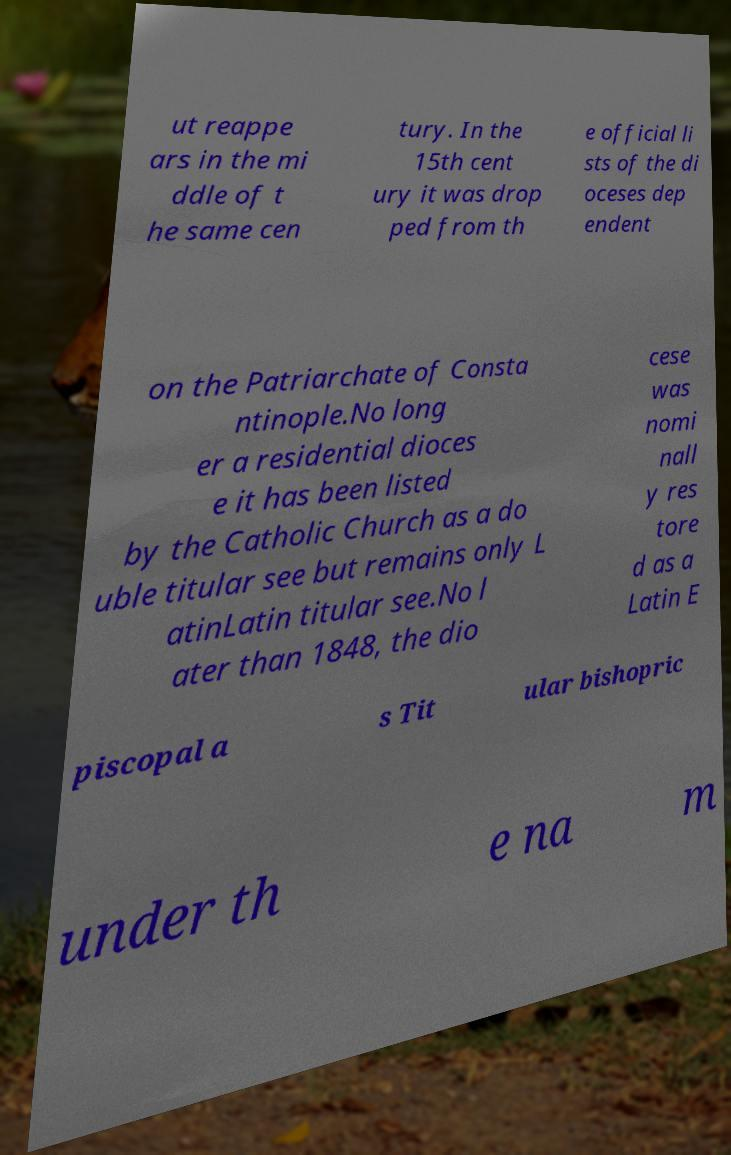Could you assist in decoding the text presented in this image and type it out clearly? ut reappe ars in the mi ddle of t he same cen tury. In the 15th cent ury it was drop ped from th e official li sts of the di oceses dep endent on the Patriarchate of Consta ntinople.No long er a residential dioces e it has been listed by the Catholic Church as a do uble titular see but remains only L atinLatin titular see.No l ater than 1848, the dio cese was nomi nall y res tore d as a Latin E piscopal a s Tit ular bishopric under th e na m 